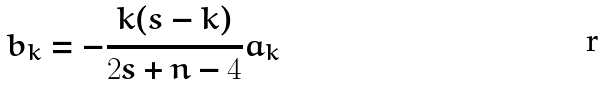<formula> <loc_0><loc_0><loc_500><loc_500>b _ { k } = - \frac { k ( s - k ) } { 2 s + n - 4 } a _ { k }</formula> 